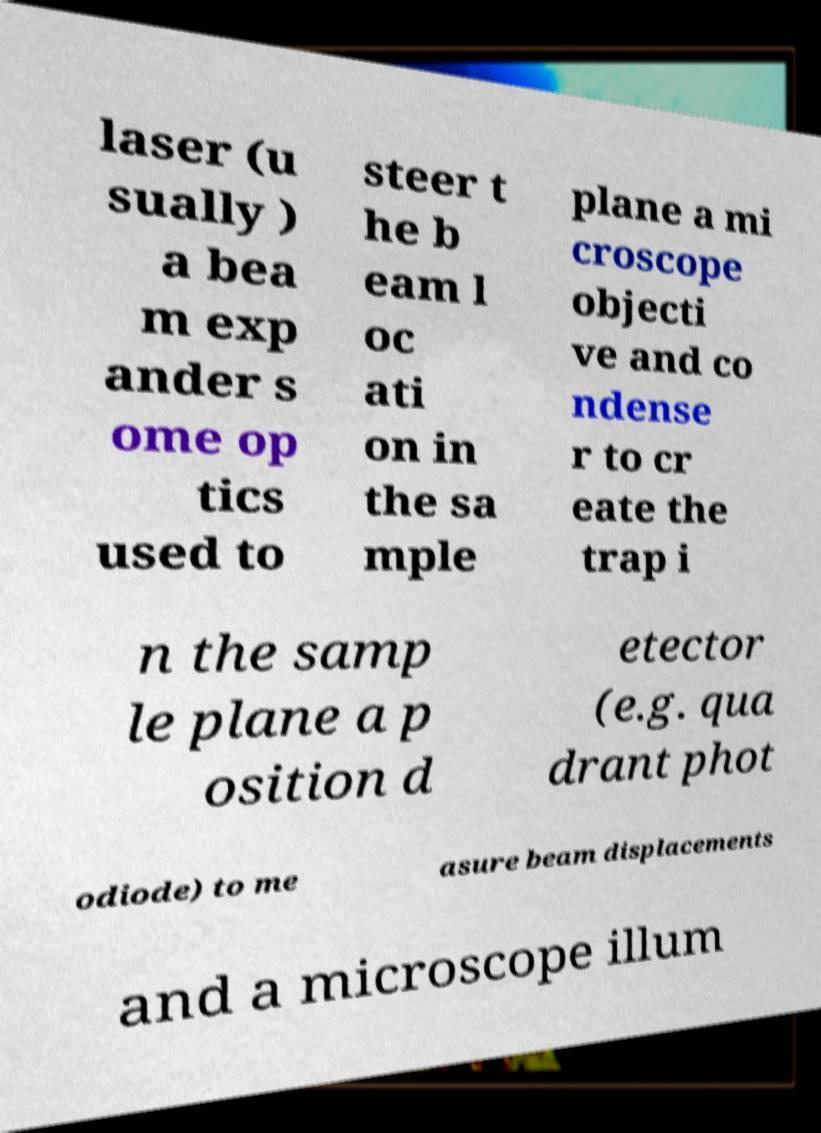Can you read and provide the text displayed in the image?This photo seems to have some interesting text. Can you extract and type it out for me? laser (u sually ) a bea m exp ander s ome op tics used to steer t he b eam l oc ati on in the sa mple plane a mi croscope objecti ve and co ndense r to cr eate the trap i n the samp le plane a p osition d etector (e.g. qua drant phot odiode) to me asure beam displacements and a microscope illum 